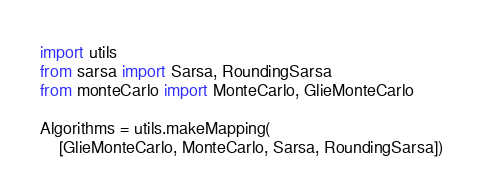Convert code to text. <code><loc_0><loc_0><loc_500><loc_500><_Python_>import utils
from sarsa import Sarsa, RoundingSarsa
from monteCarlo import MonteCarlo, GlieMonteCarlo

Algorithms = utils.makeMapping(
    [GlieMonteCarlo, MonteCarlo, Sarsa, RoundingSarsa])
</code> 